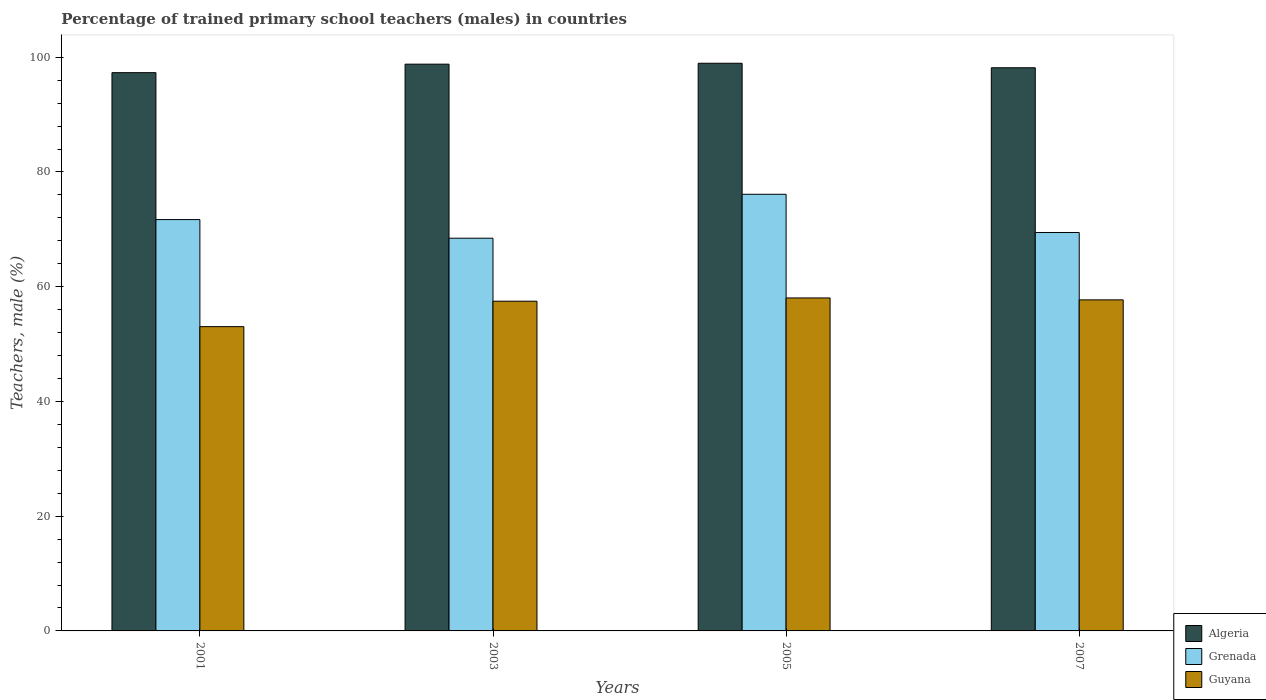What is the label of the 2nd group of bars from the left?
Ensure brevity in your answer.  2003. What is the percentage of trained primary school teachers (males) in Algeria in 2005?
Give a very brief answer. 98.95. Across all years, what is the maximum percentage of trained primary school teachers (males) in Guyana?
Provide a short and direct response. 58.04. Across all years, what is the minimum percentage of trained primary school teachers (males) in Grenada?
Your response must be concise. 68.45. In which year was the percentage of trained primary school teachers (males) in Algeria maximum?
Ensure brevity in your answer.  2005. What is the total percentage of trained primary school teachers (males) in Guyana in the graph?
Make the answer very short. 226.26. What is the difference between the percentage of trained primary school teachers (males) in Guyana in 2001 and that in 2005?
Provide a succinct answer. -5. What is the difference between the percentage of trained primary school teachers (males) in Guyana in 2007 and the percentage of trained primary school teachers (males) in Grenada in 2001?
Make the answer very short. -13.99. What is the average percentage of trained primary school teachers (males) in Guyana per year?
Ensure brevity in your answer.  56.56. In the year 2001, what is the difference between the percentage of trained primary school teachers (males) in Algeria and percentage of trained primary school teachers (males) in Grenada?
Provide a short and direct response. 25.61. What is the ratio of the percentage of trained primary school teachers (males) in Algeria in 2001 to that in 2005?
Provide a short and direct response. 0.98. Is the percentage of trained primary school teachers (males) in Algeria in 2003 less than that in 2005?
Your response must be concise. Yes. Is the difference between the percentage of trained primary school teachers (males) in Algeria in 2001 and 2003 greater than the difference between the percentage of trained primary school teachers (males) in Grenada in 2001 and 2003?
Make the answer very short. No. What is the difference between the highest and the second highest percentage of trained primary school teachers (males) in Guyana?
Keep it short and to the point. 0.33. What is the difference between the highest and the lowest percentage of trained primary school teachers (males) in Grenada?
Provide a succinct answer. 7.66. In how many years, is the percentage of trained primary school teachers (males) in Guyana greater than the average percentage of trained primary school teachers (males) in Guyana taken over all years?
Provide a short and direct response. 3. What does the 3rd bar from the left in 2001 represents?
Provide a succinct answer. Guyana. What does the 2nd bar from the right in 2003 represents?
Your response must be concise. Grenada. Is it the case that in every year, the sum of the percentage of trained primary school teachers (males) in Guyana and percentage of trained primary school teachers (males) in Grenada is greater than the percentage of trained primary school teachers (males) in Algeria?
Offer a terse response. Yes. Are all the bars in the graph horizontal?
Offer a terse response. No. How many years are there in the graph?
Provide a short and direct response. 4. Are the values on the major ticks of Y-axis written in scientific E-notation?
Offer a terse response. No. Does the graph contain grids?
Your answer should be very brief. No. Where does the legend appear in the graph?
Offer a very short reply. Bottom right. How many legend labels are there?
Your answer should be compact. 3. What is the title of the graph?
Offer a terse response. Percentage of trained primary school teachers (males) in countries. Does "Zimbabwe" appear as one of the legend labels in the graph?
Offer a very short reply. No. What is the label or title of the Y-axis?
Ensure brevity in your answer.  Teachers, male (%). What is the Teachers, male (%) of Algeria in 2001?
Give a very brief answer. 97.31. What is the Teachers, male (%) in Grenada in 2001?
Make the answer very short. 71.7. What is the Teachers, male (%) in Guyana in 2001?
Provide a succinct answer. 53.04. What is the Teachers, male (%) of Algeria in 2003?
Your response must be concise. 98.79. What is the Teachers, male (%) of Grenada in 2003?
Your answer should be compact. 68.45. What is the Teachers, male (%) of Guyana in 2003?
Ensure brevity in your answer.  57.47. What is the Teachers, male (%) in Algeria in 2005?
Make the answer very short. 98.95. What is the Teachers, male (%) in Grenada in 2005?
Provide a succinct answer. 76.11. What is the Teachers, male (%) in Guyana in 2005?
Give a very brief answer. 58.04. What is the Teachers, male (%) in Algeria in 2007?
Make the answer very short. 98.16. What is the Teachers, male (%) of Grenada in 2007?
Offer a terse response. 69.45. What is the Teachers, male (%) in Guyana in 2007?
Offer a terse response. 57.71. Across all years, what is the maximum Teachers, male (%) in Algeria?
Ensure brevity in your answer.  98.95. Across all years, what is the maximum Teachers, male (%) of Grenada?
Your response must be concise. 76.11. Across all years, what is the maximum Teachers, male (%) of Guyana?
Keep it short and to the point. 58.04. Across all years, what is the minimum Teachers, male (%) in Algeria?
Your answer should be very brief. 97.31. Across all years, what is the minimum Teachers, male (%) of Grenada?
Offer a terse response. 68.45. Across all years, what is the minimum Teachers, male (%) in Guyana?
Provide a succinct answer. 53.04. What is the total Teachers, male (%) in Algeria in the graph?
Your answer should be very brief. 393.21. What is the total Teachers, male (%) of Grenada in the graph?
Give a very brief answer. 285.71. What is the total Teachers, male (%) of Guyana in the graph?
Offer a terse response. 226.26. What is the difference between the Teachers, male (%) in Algeria in 2001 and that in 2003?
Provide a short and direct response. -1.48. What is the difference between the Teachers, male (%) of Grenada in 2001 and that in 2003?
Offer a terse response. 3.25. What is the difference between the Teachers, male (%) in Guyana in 2001 and that in 2003?
Keep it short and to the point. -4.43. What is the difference between the Teachers, male (%) in Algeria in 2001 and that in 2005?
Offer a very short reply. -1.64. What is the difference between the Teachers, male (%) in Grenada in 2001 and that in 2005?
Provide a short and direct response. -4.41. What is the difference between the Teachers, male (%) in Guyana in 2001 and that in 2005?
Offer a terse response. -5. What is the difference between the Teachers, male (%) of Algeria in 2001 and that in 2007?
Your answer should be compact. -0.85. What is the difference between the Teachers, male (%) in Grenada in 2001 and that in 2007?
Your answer should be compact. 2.25. What is the difference between the Teachers, male (%) in Guyana in 2001 and that in 2007?
Your answer should be very brief. -4.67. What is the difference between the Teachers, male (%) of Algeria in 2003 and that in 2005?
Your answer should be very brief. -0.16. What is the difference between the Teachers, male (%) in Grenada in 2003 and that in 2005?
Give a very brief answer. -7.66. What is the difference between the Teachers, male (%) in Guyana in 2003 and that in 2005?
Ensure brevity in your answer.  -0.57. What is the difference between the Teachers, male (%) of Algeria in 2003 and that in 2007?
Your answer should be compact. 0.63. What is the difference between the Teachers, male (%) in Grenada in 2003 and that in 2007?
Your answer should be compact. -1. What is the difference between the Teachers, male (%) of Guyana in 2003 and that in 2007?
Your answer should be very brief. -0.23. What is the difference between the Teachers, male (%) in Algeria in 2005 and that in 2007?
Keep it short and to the point. 0.79. What is the difference between the Teachers, male (%) of Grenada in 2005 and that in 2007?
Your answer should be very brief. 6.66. What is the difference between the Teachers, male (%) of Guyana in 2005 and that in 2007?
Keep it short and to the point. 0.33. What is the difference between the Teachers, male (%) in Algeria in 2001 and the Teachers, male (%) in Grenada in 2003?
Your answer should be very brief. 28.86. What is the difference between the Teachers, male (%) of Algeria in 2001 and the Teachers, male (%) of Guyana in 2003?
Your answer should be compact. 39.84. What is the difference between the Teachers, male (%) of Grenada in 2001 and the Teachers, male (%) of Guyana in 2003?
Your answer should be compact. 14.23. What is the difference between the Teachers, male (%) in Algeria in 2001 and the Teachers, male (%) in Grenada in 2005?
Offer a terse response. 21.2. What is the difference between the Teachers, male (%) in Algeria in 2001 and the Teachers, male (%) in Guyana in 2005?
Make the answer very short. 39.27. What is the difference between the Teachers, male (%) of Grenada in 2001 and the Teachers, male (%) of Guyana in 2005?
Your answer should be compact. 13.66. What is the difference between the Teachers, male (%) of Algeria in 2001 and the Teachers, male (%) of Grenada in 2007?
Provide a succinct answer. 27.86. What is the difference between the Teachers, male (%) in Algeria in 2001 and the Teachers, male (%) in Guyana in 2007?
Make the answer very short. 39.6. What is the difference between the Teachers, male (%) in Grenada in 2001 and the Teachers, male (%) in Guyana in 2007?
Your answer should be compact. 13.99. What is the difference between the Teachers, male (%) of Algeria in 2003 and the Teachers, male (%) of Grenada in 2005?
Ensure brevity in your answer.  22.68. What is the difference between the Teachers, male (%) of Algeria in 2003 and the Teachers, male (%) of Guyana in 2005?
Your answer should be compact. 40.75. What is the difference between the Teachers, male (%) of Grenada in 2003 and the Teachers, male (%) of Guyana in 2005?
Your response must be concise. 10.41. What is the difference between the Teachers, male (%) in Algeria in 2003 and the Teachers, male (%) in Grenada in 2007?
Provide a succinct answer. 29.34. What is the difference between the Teachers, male (%) of Algeria in 2003 and the Teachers, male (%) of Guyana in 2007?
Offer a terse response. 41.08. What is the difference between the Teachers, male (%) of Grenada in 2003 and the Teachers, male (%) of Guyana in 2007?
Your answer should be very brief. 10.75. What is the difference between the Teachers, male (%) of Algeria in 2005 and the Teachers, male (%) of Grenada in 2007?
Give a very brief answer. 29.5. What is the difference between the Teachers, male (%) of Algeria in 2005 and the Teachers, male (%) of Guyana in 2007?
Give a very brief answer. 41.24. What is the difference between the Teachers, male (%) in Grenada in 2005 and the Teachers, male (%) in Guyana in 2007?
Provide a short and direct response. 18.41. What is the average Teachers, male (%) of Algeria per year?
Give a very brief answer. 98.3. What is the average Teachers, male (%) of Grenada per year?
Keep it short and to the point. 71.43. What is the average Teachers, male (%) of Guyana per year?
Offer a terse response. 56.56. In the year 2001, what is the difference between the Teachers, male (%) in Algeria and Teachers, male (%) in Grenada?
Offer a terse response. 25.61. In the year 2001, what is the difference between the Teachers, male (%) in Algeria and Teachers, male (%) in Guyana?
Offer a very short reply. 44.27. In the year 2001, what is the difference between the Teachers, male (%) in Grenada and Teachers, male (%) in Guyana?
Give a very brief answer. 18.66. In the year 2003, what is the difference between the Teachers, male (%) of Algeria and Teachers, male (%) of Grenada?
Your answer should be compact. 30.34. In the year 2003, what is the difference between the Teachers, male (%) of Algeria and Teachers, male (%) of Guyana?
Provide a short and direct response. 41.32. In the year 2003, what is the difference between the Teachers, male (%) in Grenada and Teachers, male (%) in Guyana?
Provide a succinct answer. 10.98. In the year 2005, what is the difference between the Teachers, male (%) of Algeria and Teachers, male (%) of Grenada?
Offer a very short reply. 22.84. In the year 2005, what is the difference between the Teachers, male (%) in Algeria and Teachers, male (%) in Guyana?
Offer a very short reply. 40.91. In the year 2005, what is the difference between the Teachers, male (%) of Grenada and Teachers, male (%) of Guyana?
Offer a terse response. 18.07. In the year 2007, what is the difference between the Teachers, male (%) in Algeria and Teachers, male (%) in Grenada?
Make the answer very short. 28.71. In the year 2007, what is the difference between the Teachers, male (%) in Algeria and Teachers, male (%) in Guyana?
Keep it short and to the point. 40.46. In the year 2007, what is the difference between the Teachers, male (%) of Grenada and Teachers, male (%) of Guyana?
Your answer should be very brief. 11.74. What is the ratio of the Teachers, male (%) in Grenada in 2001 to that in 2003?
Keep it short and to the point. 1.05. What is the ratio of the Teachers, male (%) in Guyana in 2001 to that in 2003?
Provide a short and direct response. 0.92. What is the ratio of the Teachers, male (%) of Algeria in 2001 to that in 2005?
Offer a terse response. 0.98. What is the ratio of the Teachers, male (%) in Grenada in 2001 to that in 2005?
Ensure brevity in your answer.  0.94. What is the ratio of the Teachers, male (%) in Guyana in 2001 to that in 2005?
Your answer should be compact. 0.91. What is the ratio of the Teachers, male (%) in Grenada in 2001 to that in 2007?
Offer a terse response. 1.03. What is the ratio of the Teachers, male (%) in Guyana in 2001 to that in 2007?
Give a very brief answer. 0.92. What is the ratio of the Teachers, male (%) of Algeria in 2003 to that in 2005?
Offer a terse response. 1. What is the ratio of the Teachers, male (%) in Grenada in 2003 to that in 2005?
Your answer should be compact. 0.9. What is the ratio of the Teachers, male (%) of Guyana in 2003 to that in 2005?
Provide a short and direct response. 0.99. What is the ratio of the Teachers, male (%) of Algeria in 2003 to that in 2007?
Provide a short and direct response. 1.01. What is the ratio of the Teachers, male (%) of Grenada in 2003 to that in 2007?
Offer a terse response. 0.99. What is the ratio of the Teachers, male (%) in Guyana in 2003 to that in 2007?
Your answer should be compact. 1. What is the ratio of the Teachers, male (%) in Algeria in 2005 to that in 2007?
Make the answer very short. 1.01. What is the ratio of the Teachers, male (%) of Grenada in 2005 to that in 2007?
Your answer should be compact. 1.1. What is the ratio of the Teachers, male (%) of Guyana in 2005 to that in 2007?
Your answer should be compact. 1.01. What is the difference between the highest and the second highest Teachers, male (%) of Algeria?
Provide a short and direct response. 0.16. What is the difference between the highest and the second highest Teachers, male (%) of Grenada?
Offer a very short reply. 4.41. What is the difference between the highest and the second highest Teachers, male (%) in Guyana?
Provide a succinct answer. 0.33. What is the difference between the highest and the lowest Teachers, male (%) of Algeria?
Make the answer very short. 1.64. What is the difference between the highest and the lowest Teachers, male (%) in Grenada?
Offer a terse response. 7.66. What is the difference between the highest and the lowest Teachers, male (%) of Guyana?
Your answer should be very brief. 5. 